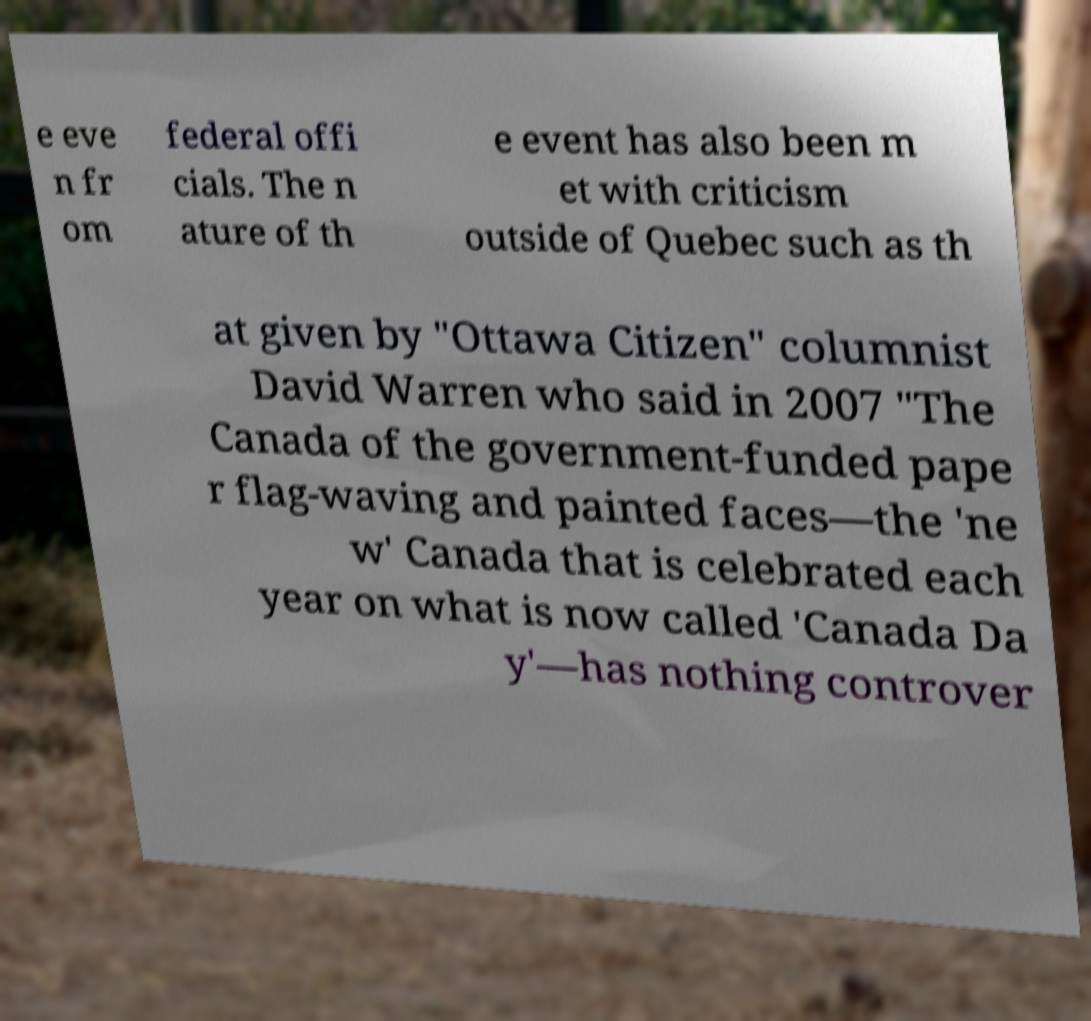What messages or text are displayed in this image? I need them in a readable, typed format. e eve n fr om federal offi cials. The n ature of th e event has also been m et with criticism outside of Quebec such as th at given by "Ottawa Citizen" columnist David Warren who said in 2007 "The Canada of the government-funded pape r flag-waving and painted faces—the 'ne w' Canada that is celebrated each year on what is now called 'Canada Da y'—has nothing controver 